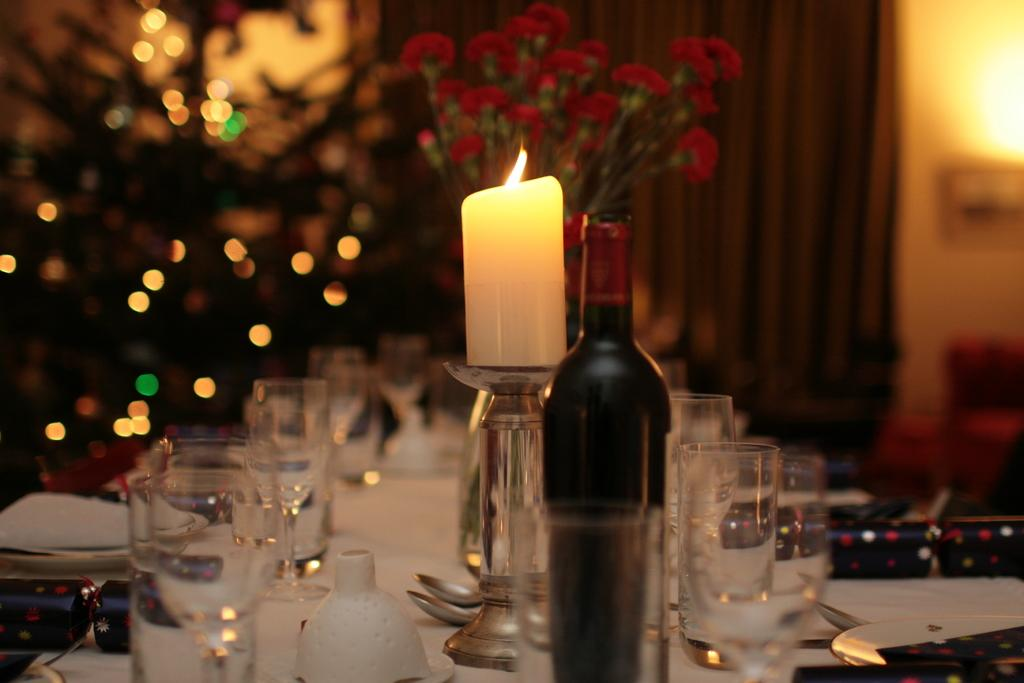What type of furniture is present in the image? There is a table in the image. What items can be seen on the table? The table contains glasses, flowers, a candle, and a bottle. Can you describe the table setting in the image? The table contains a variety of items, including glasses, flowers, a candle, and a bottle. What can be inferred about the background of the image? The background of the image is blurred. How many giants are visible in the image? There are no giants present in the image. What type of cup is being used to hold the flowers on the table? There is no cup visible in the image; the flowers are not in a cup but rather on the table alongside other items. 